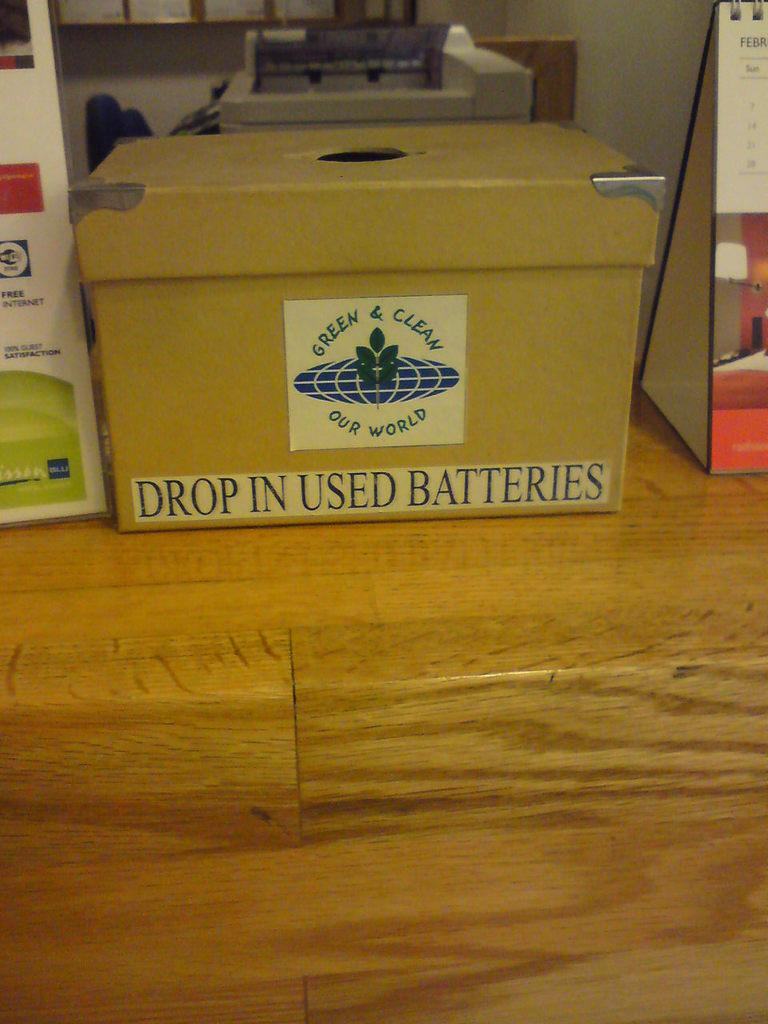Provide a one-sentence caption for the provided image. A box with an opening on top is labeled as a place to drop used batteries. 